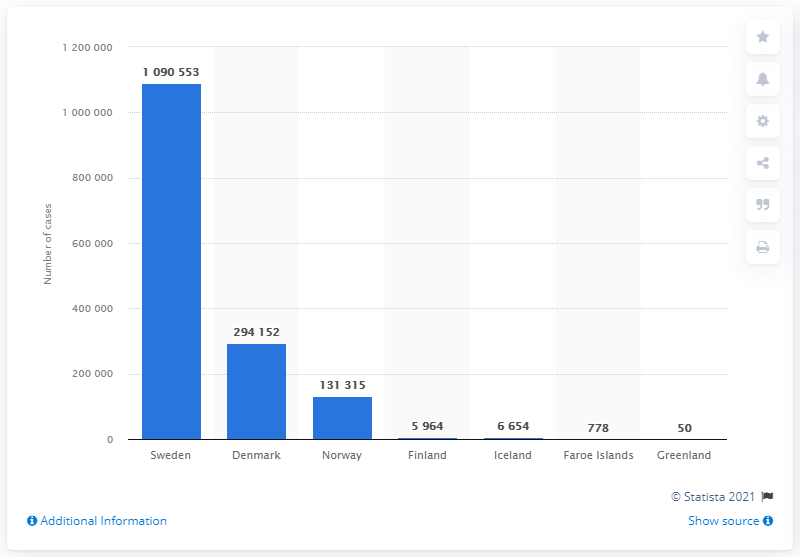List a handful of essential elements in this visual. On July 1, 2021, Norway had the highest number of confirmed coronavirus cases, according to official statistics. As of July 1, 2021, Sweden had the highest number of confirmed coronavirus cases, according to the latest statistics. 